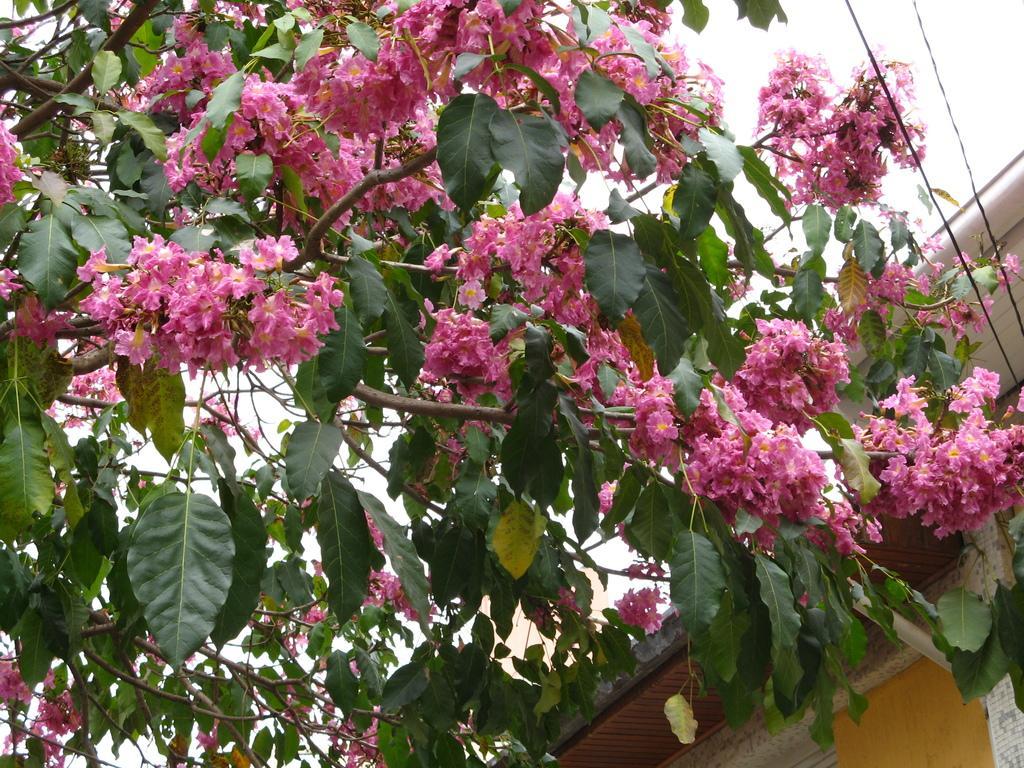Could you give a brief overview of what you see in this image? This image is taken outdoors. At the top of the image there is the sky. On the right side of the image there is a house with walls and a roof. On the left side of the image there is a tree with stems, branches, leaves and flowers. Those flowers are pink in color. 